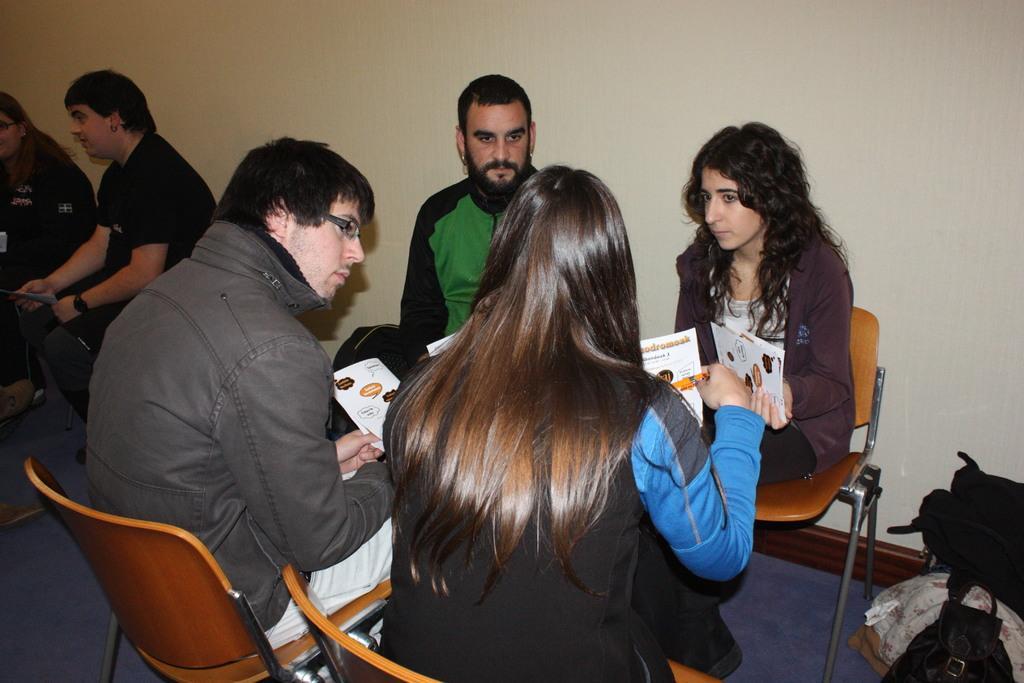Describe this image in one or two sentences. One two three four five six, there are five six people on the chair in a room. Among them, there are girls and three are boys, women woman in the on the right most is holding the book and seeing the other woman on the opposite side. Woman on the opposite side is also holding the book and she is wearing a blue and black jacket. Next to her, the man wearing spectacles is also holding the book and he is wearing grey color jacket. Opposite to him, the man wearing black and green jacket and he is also looking the man carrying holding the book. To the left most, we see women wearing spectacles. To the left of her, we see man wearing watch, and he is wearing a black color t-shirt and he is also holding book. 